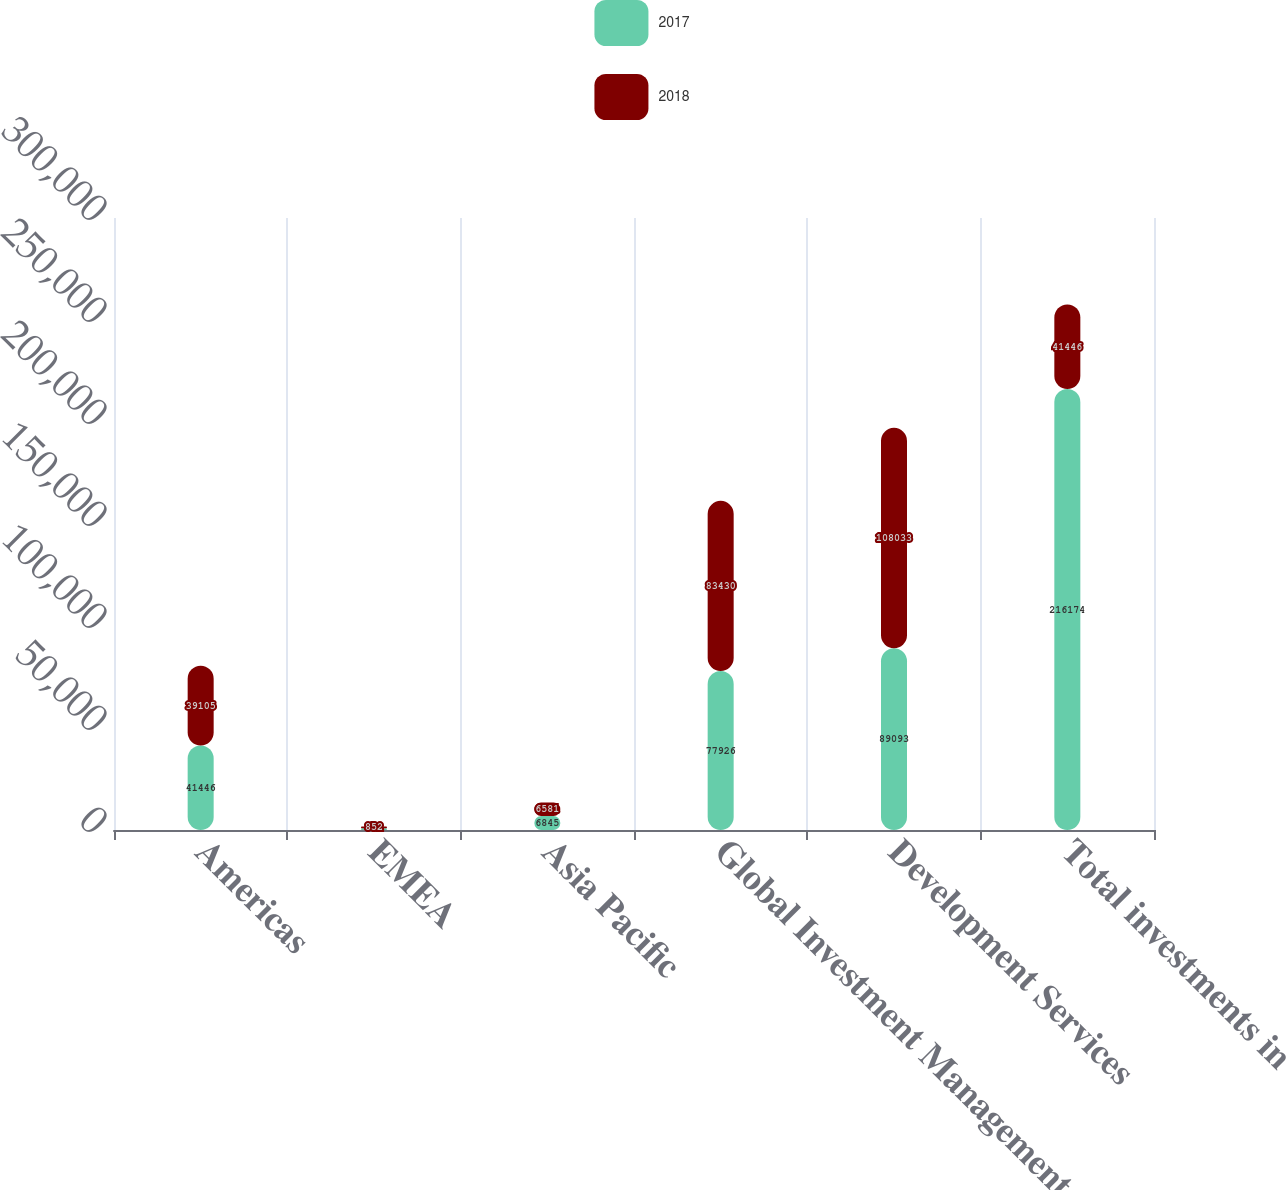Convert chart. <chart><loc_0><loc_0><loc_500><loc_500><stacked_bar_chart><ecel><fcel>Americas<fcel>EMEA<fcel>Asia Pacific<fcel>Global Investment Management<fcel>Development Services<fcel>Total investments in<nl><fcel>2017<fcel>41446<fcel>864<fcel>6845<fcel>77926<fcel>89093<fcel>216174<nl><fcel>2018<fcel>39105<fcel>852<fcel>6581<fcel>83430<fcel>108033<fcel>41446<nl></chart> 